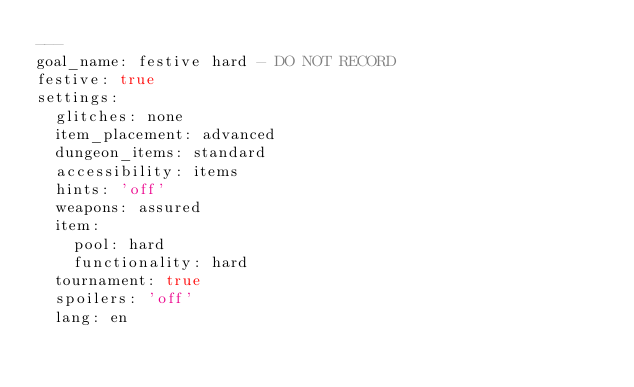Convert code to text. <code><loc_0><loc_0><loc_500><loc_500><_YAML_>---
goal_name: festive hard - DO NOT RECORD
festive: true
settings:
  glitches: none
  item_placement: advanced
  dungeon_items: standard
  accessibility: items
  hints: 'off'
  weapons: assured
  item:
    pool: hard
    functionality: hard
  tournament: true
  spoilers: 'off'
  lang: en
</code> 